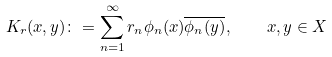Convert formula to latex. <formula><loc_0><loc_0><loc_500><loc_500>K _ { r } ( x , y ) \colon = \sum _ { n = 1 } ^ { \infty } r _ { n } \phi _ { n } ( x ) \overline { \phi _ { n } ( y ) } , \quad x , y \in X</formula> 